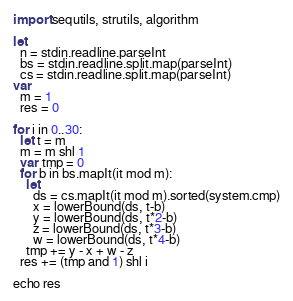Convert code to text. <code><loc_0><loc_0><loc_500><loc_500><_Nim_>import sequtils, strutils, algorithm

let
  n = stdin.readline.parseInt
  bs = stdin.readline.split.map(parseInt)
  cs = stdin.readline.split.map(parseInt)
var
  m = 1
  res = 0

for i in 0..30:
  let t = m
  m = m shl 1
  var tmp = 0
  for b in bs.mapIt(it mod m):
    let
      ds = cs.mapIt(it mod m).sorted(system.cmp)
      x = lowerBound(ds, t-b)
      y = lowerBound(ds, t*2-b)
      z = lowerBound(ds, t*3-b)
      w = lowerBound(ds, t*4-b)
    tmp += y - x + w - z
  res += (tmp and 1) shl i

echo res
</code> 